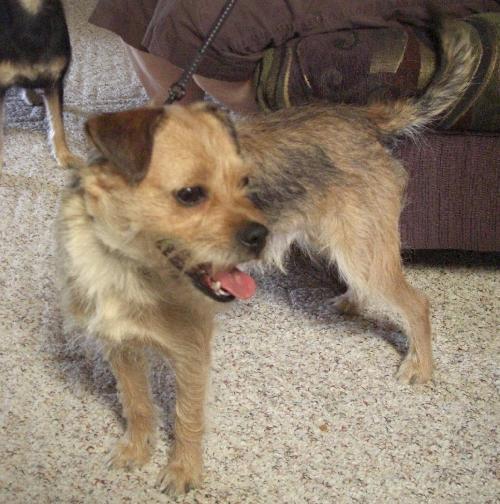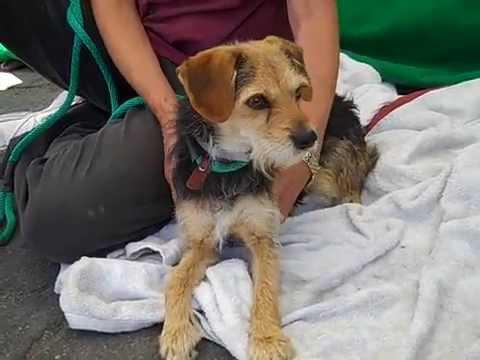The first image is the image on the left, the second image is the image on the right. Considering the images on both sides, is "A dog is on carpet in one picture and on a blanket in the other picture." valid? Answer yes or no. Yes. The first image is the image on the left, the second image is the image on the right. For the images displayed, is the sentence "The dog in the right image has a green leash." factually correct? Answer yes or no. Yes. 